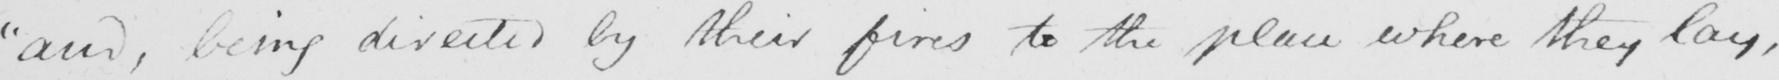Can you read and transcribe this handwriting? " and , being directed by their fires to the place where they lay , 